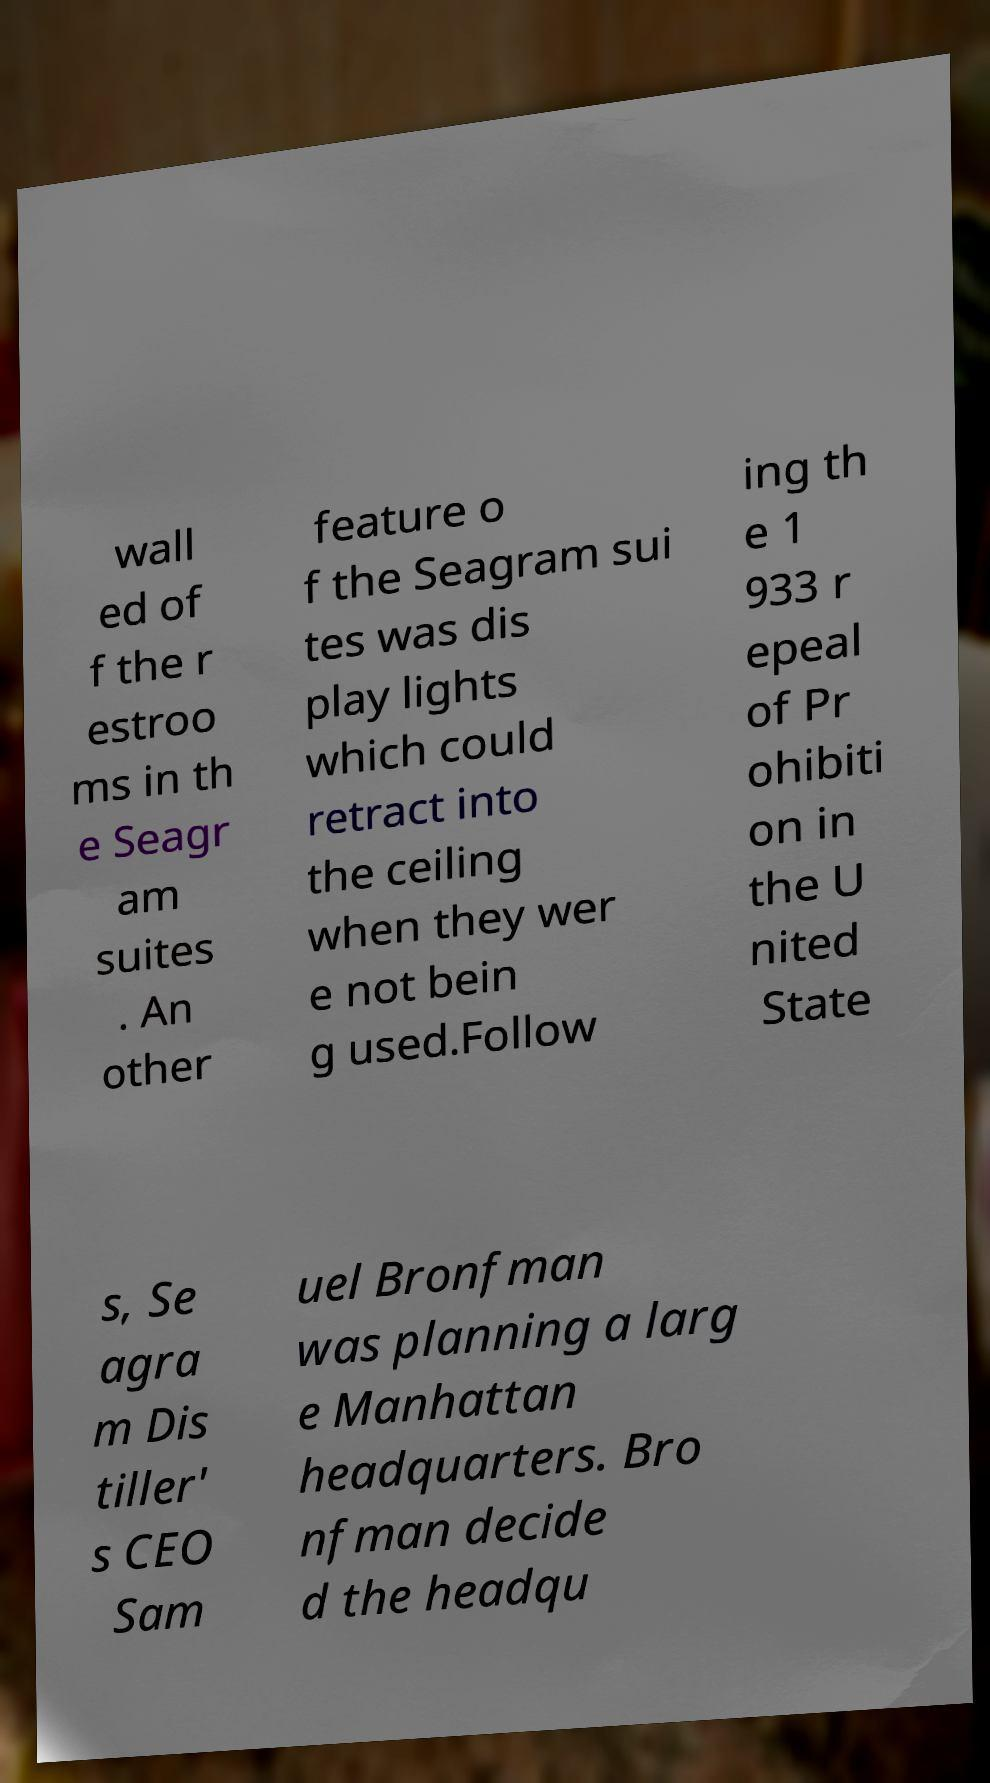Could you assist in decoding the text presented in this image and type it out clearly? wall ed of f the r estroo ms in th e Seagr am suites . An other feature o f the Seagram sui tes was dis play lights which could retract into the ceiling when they wer e not bein g used.Follow ing th e 1 933 r epeal of Pr ohibiti on in the U nited State s, Se agra m Dis tiller' s CEO Sam uel Bronfman was planning a larg e Manhattan headquarters. Bro nfman decide d the headqu 